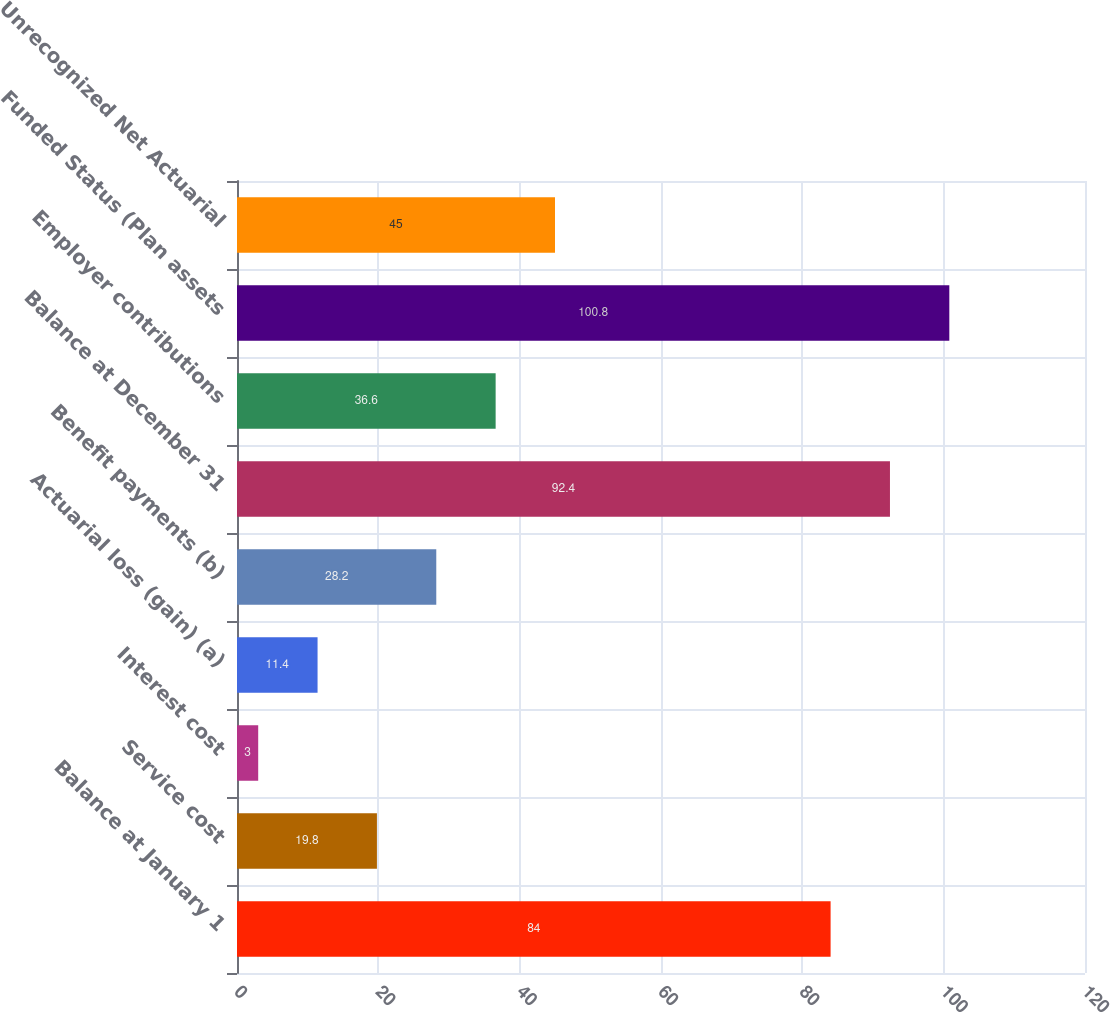Convert chart. <chart><loc_0><loc_0><loc_500><loc_500><bar_chart><fcel>Balance at January 1<fcel>Service cost<fcel>Interest cost<fcel>Actuarial loss (gain) (a)<fcel>Benefit payments (b)<fcel>Balance at December 31<fcel>Employer contributions<fcel>Funded Status (Plan assets<fcel>Unrecognized Net Actuarial<nl><fcel>84<fcel>19.8<fcel>3<fcel>11.4<fcel>28.2<fcel>92.4<fcel>36.6<fcel>100.8<fcel>45<nl></chart> 